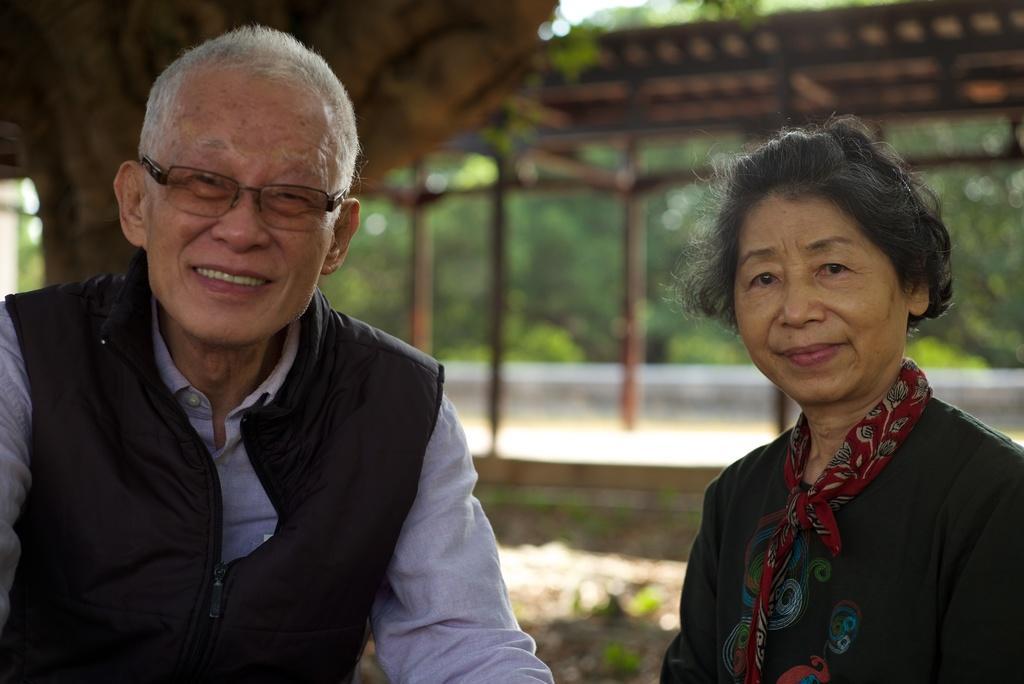Describe this image in one or two sentences. In this I can see on the left side an old man is laughing, he wore black color coat, spectacles. On the right side a woman is looking at this side, she wore sweater and a scarp. Behind them there is an iron shed, at the back side there are trees. 